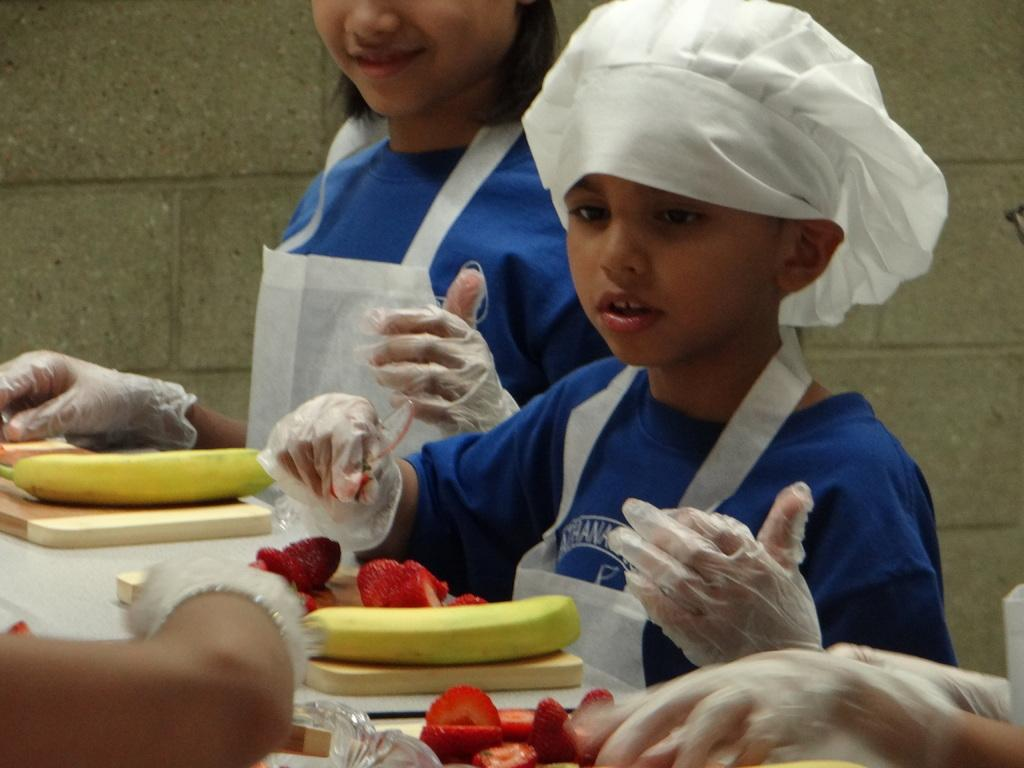What are the people in the image doing? The persons are standing in front of the table. What type of fruit can be seen on the table? There are bananas and strawberries on the table. What else can be found on the table besides fruit? There are other objects on the table. What can be seen in the background of the image? There is a wall in the background of the image. How many arms are visible in the image? There is no specific mention of arms in the image, so it is not possible to determine the number of arms visible. 